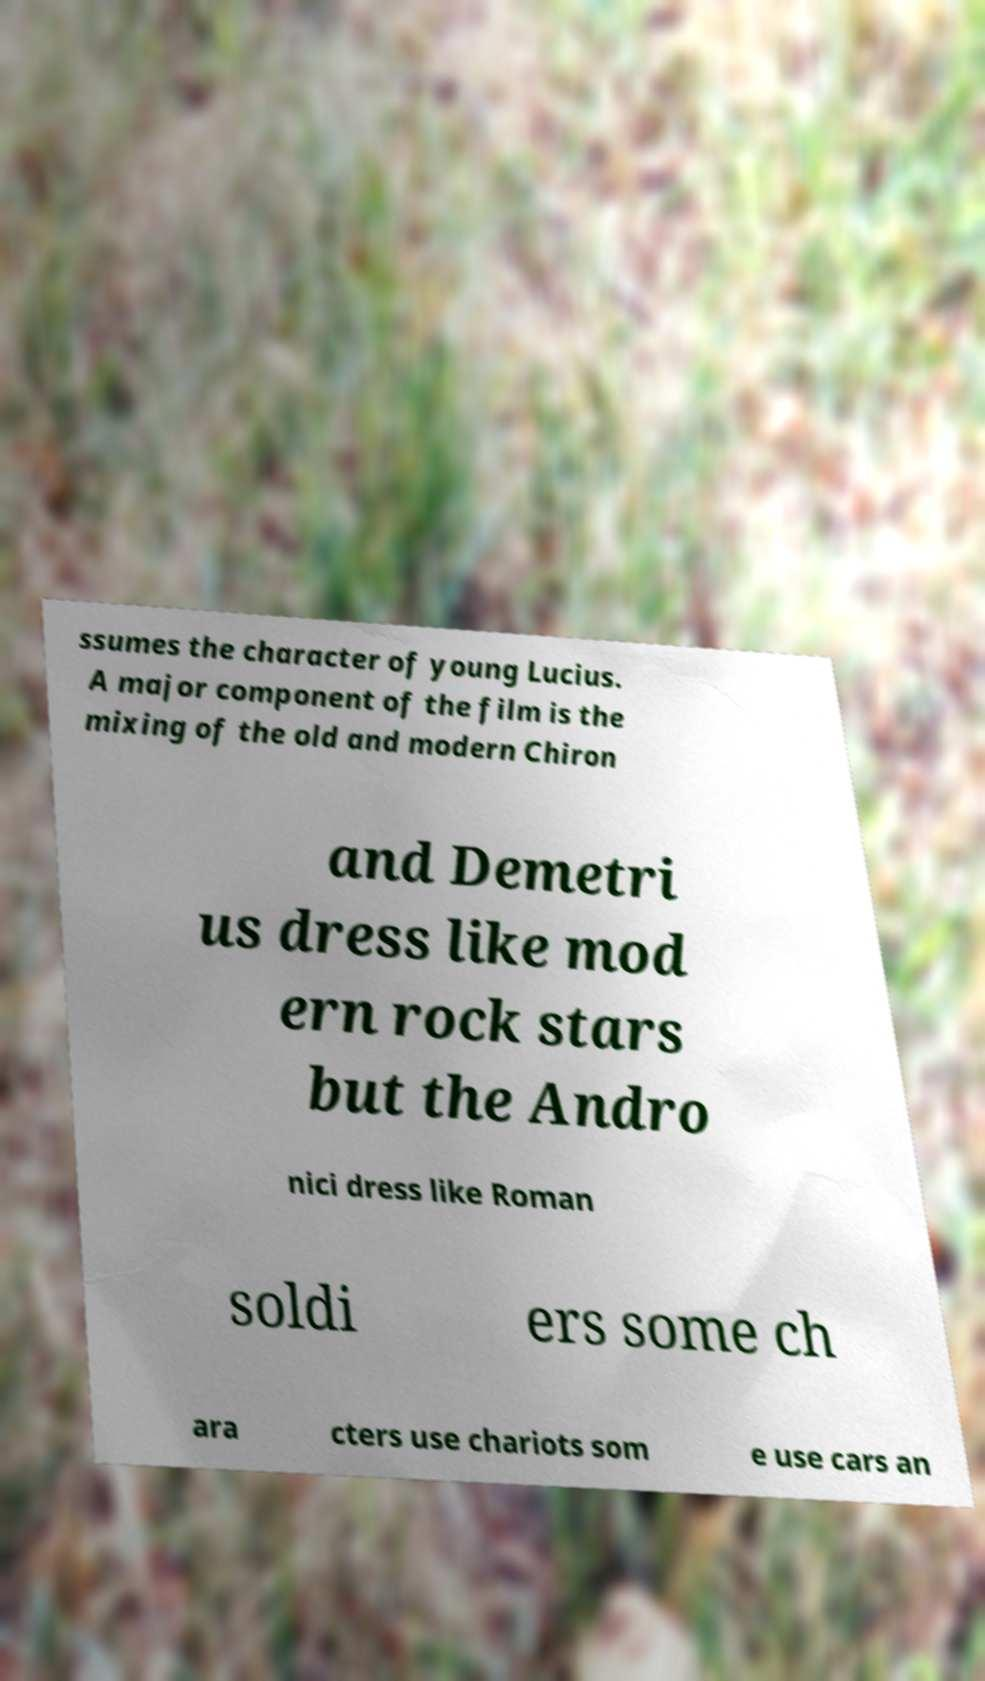What messages or text are displayed in this image? I need them in a readable, typed format. ssumes the character of young Lucius. A major component of the film is the mixing of the old and modern Chiron and Demetri us dress like mod ern rock stars but the Andro nici dress like Roman soldi ers some ch ara cters use chariots som e use cars an 